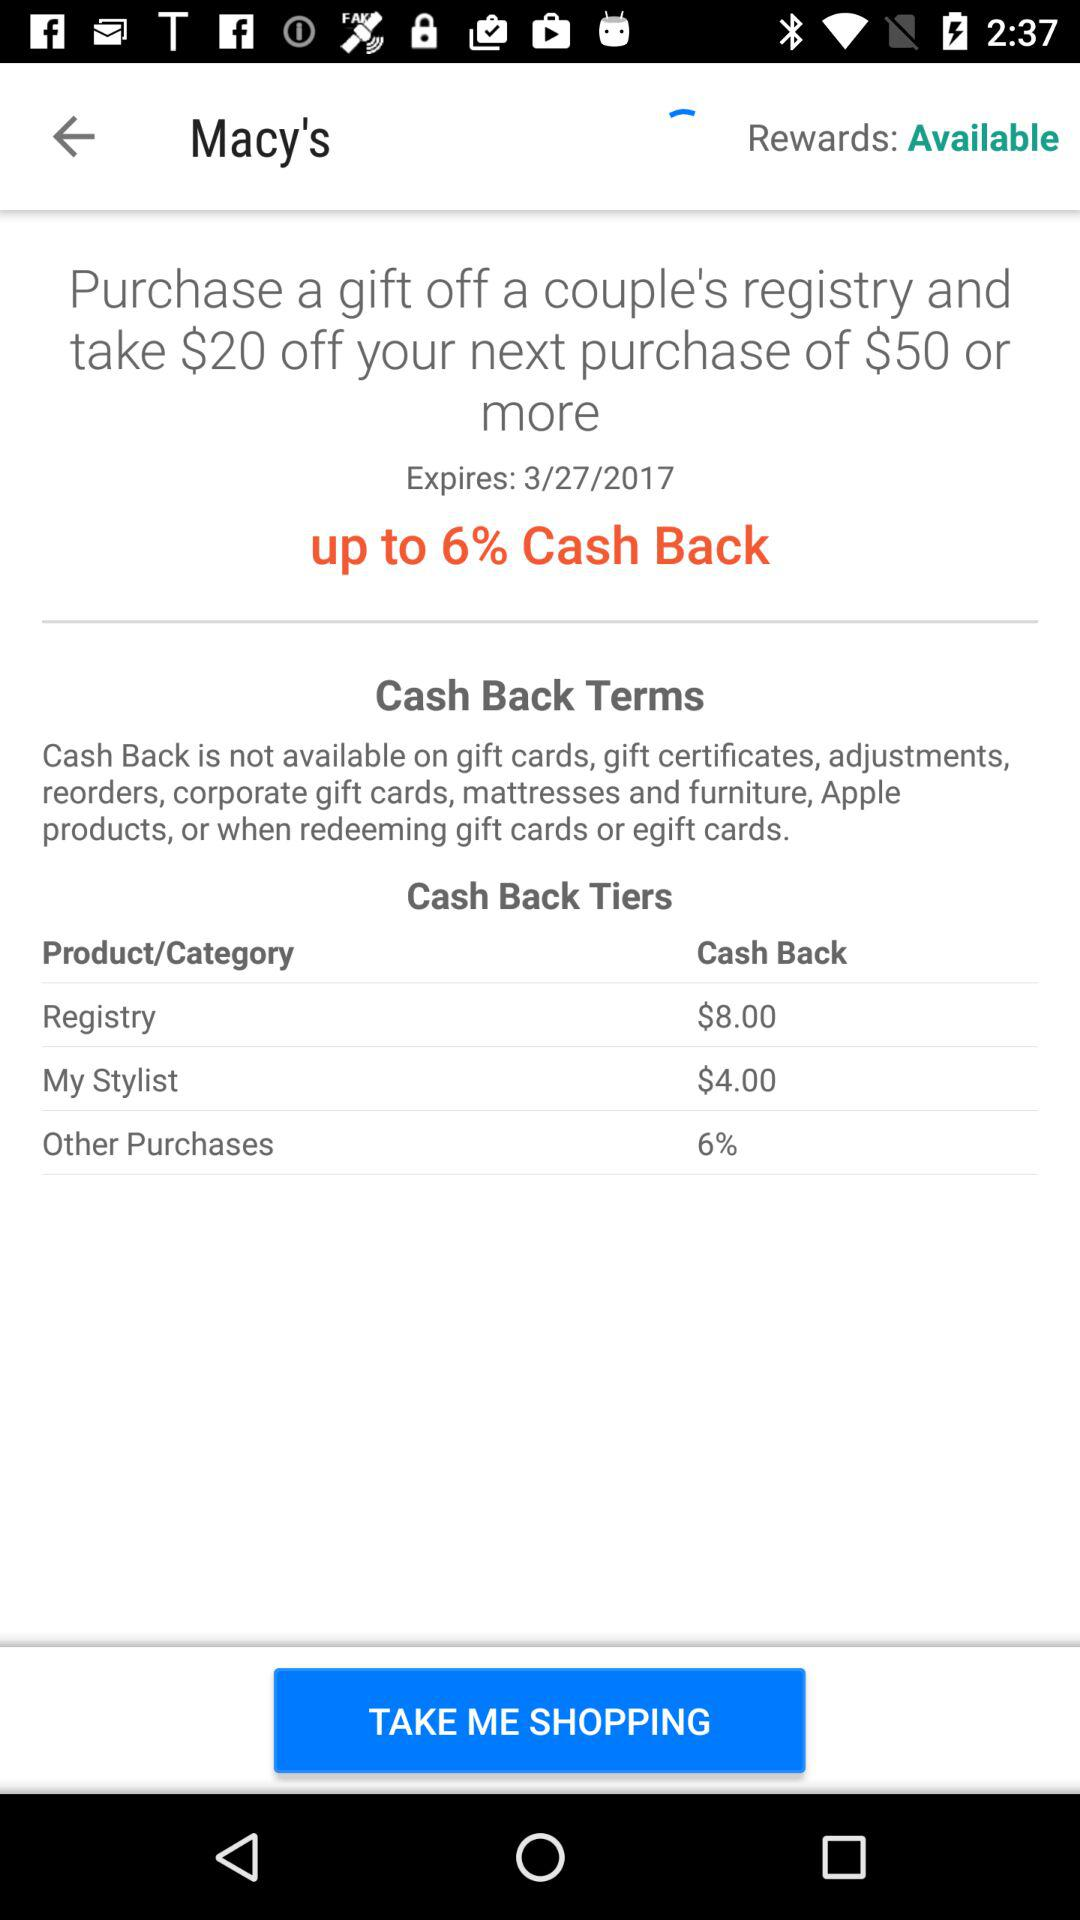What is the application name? The application name is "Macy's". 